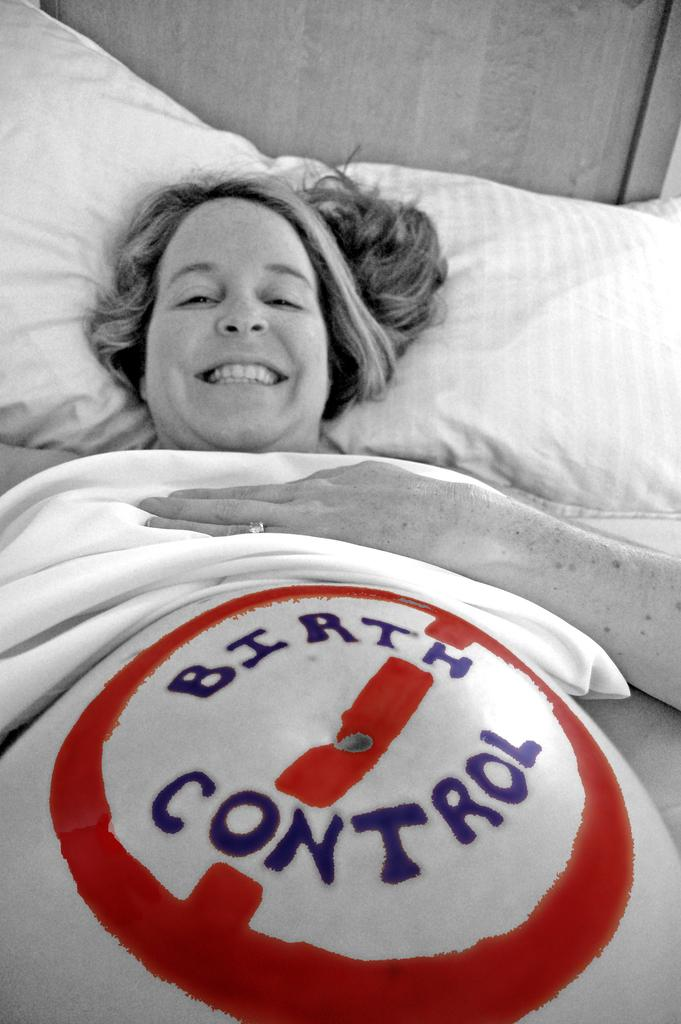What is the main subject of the image? There is a person in the image. Where is the person located? The person is on a bed. What is the color scheme of the image? The image is black and white. What type of nation is depicted in the image? There is no nation depicted in the image; it features a person on a bed in a black and white setting. What substance is being used to open the door in the image? There is no door or substance present in the image; it only shows a person on a bed in a black and white setting. 